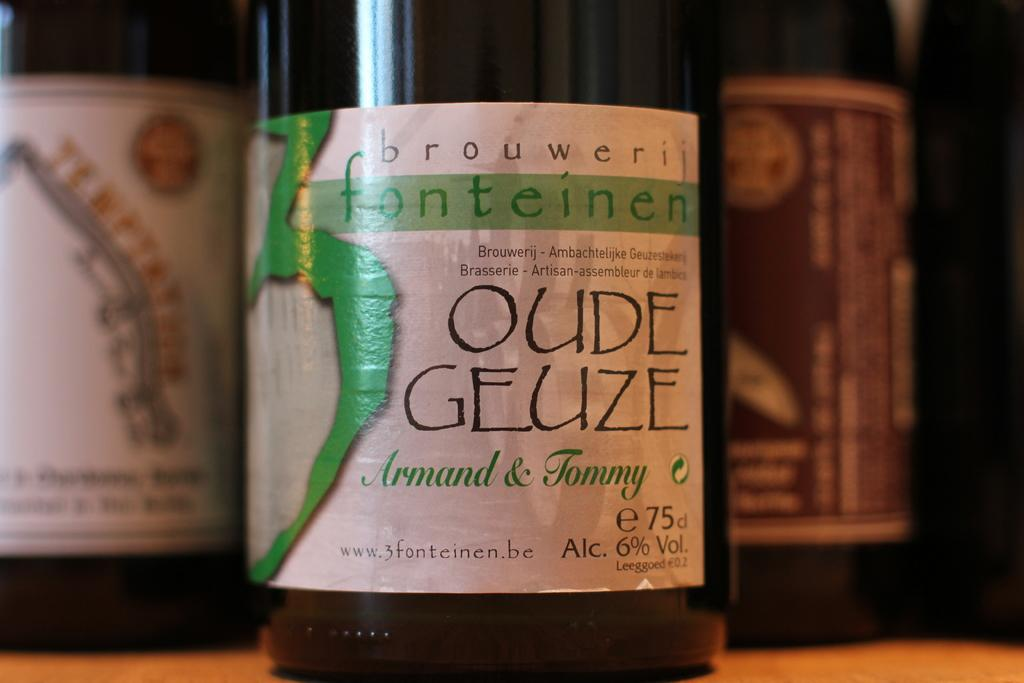<image>
Give a short and clear explanation of the subsequent image. Bottle of Oude Geuze Armand & Tommy beer on a table. 